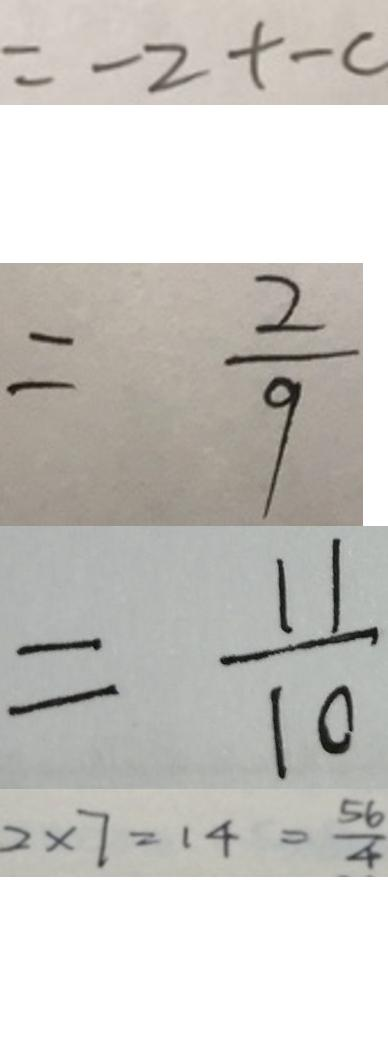Convert formula to latex. <formula><loc_0><loc_0><loc_500><loc_500>= - 2 + - c 
 = \frac { 2 } { 9 } 
 = \frac { 1 1 } { 1 0 } 
 2 \times 7 = 1 4 = \frac { 5 6 } { 4 }</formula> 